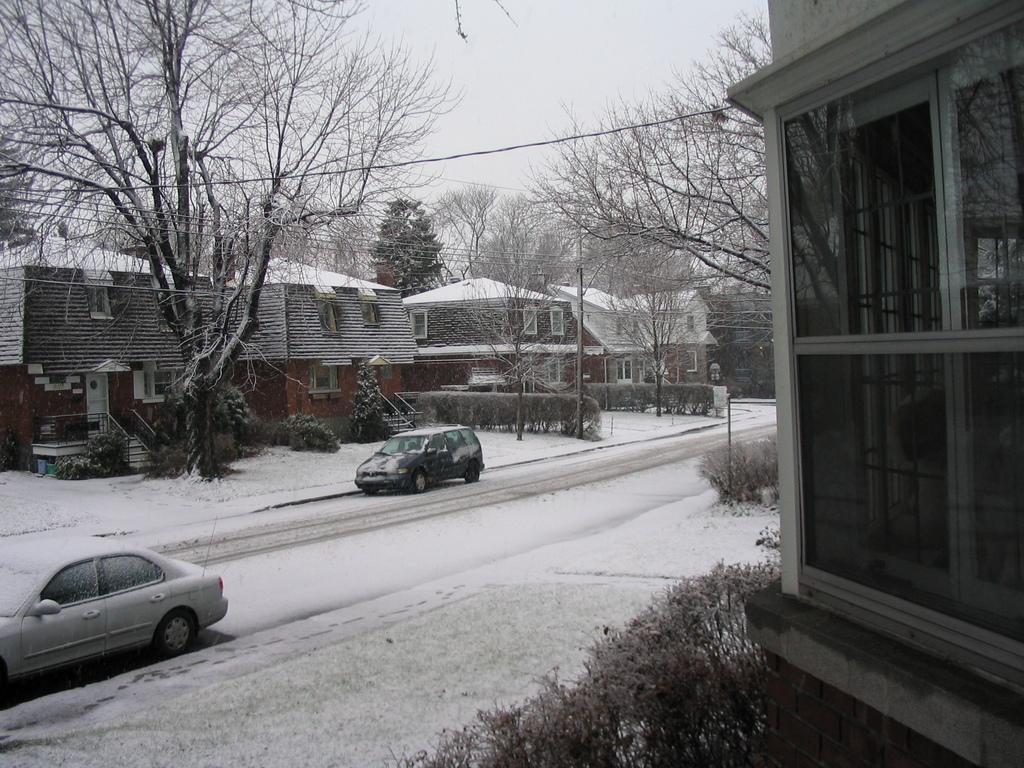Could you give a brief overview of what you see in this image? In this picture I can see number of houses and I see the road in the middle of this picture on which there are 2 cars and I see the white snow and I can see the plants, trees, wires and a pole. In the background I see the sky. 